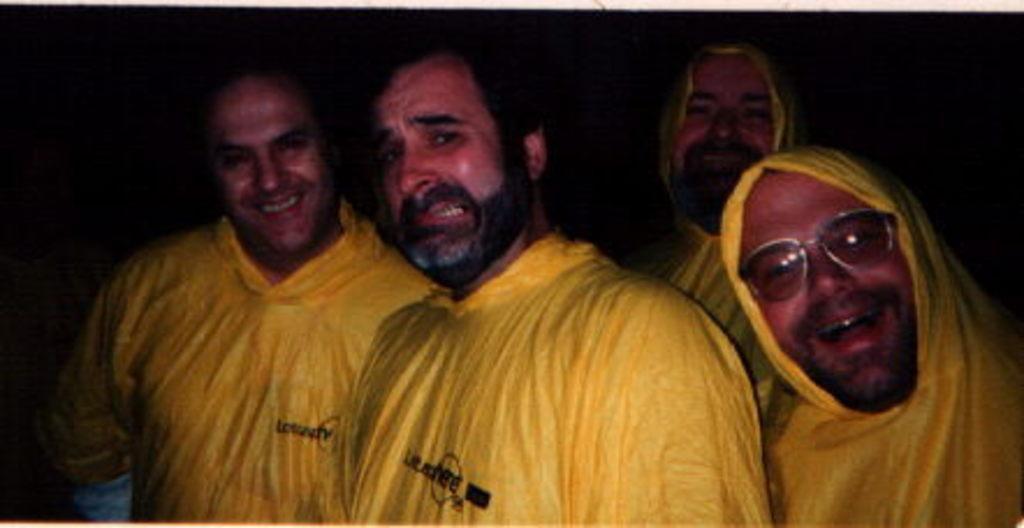Describe this image in one or two sentences. In this image we can see few people. One person is wearing specs. In the background it is dark. 